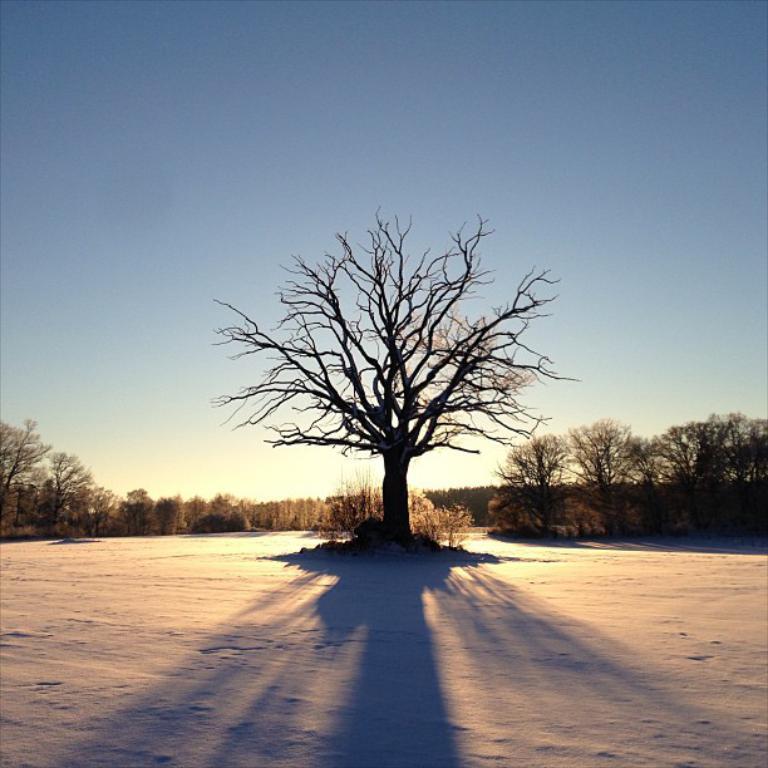Can you describe this image briefly? In this image there are trees, shadow and sky.   